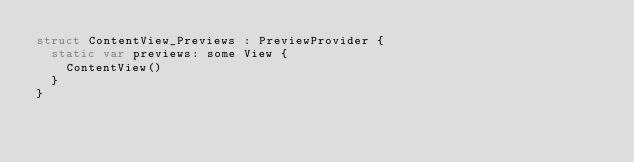Convert code to text. <code><loc_0><loc_0><loc_500><loc_500><_Swift_>struct ContentView_Previews : PreviewProvider {
  static var previews: some View {
    ContentView()
  }
}
</code> 